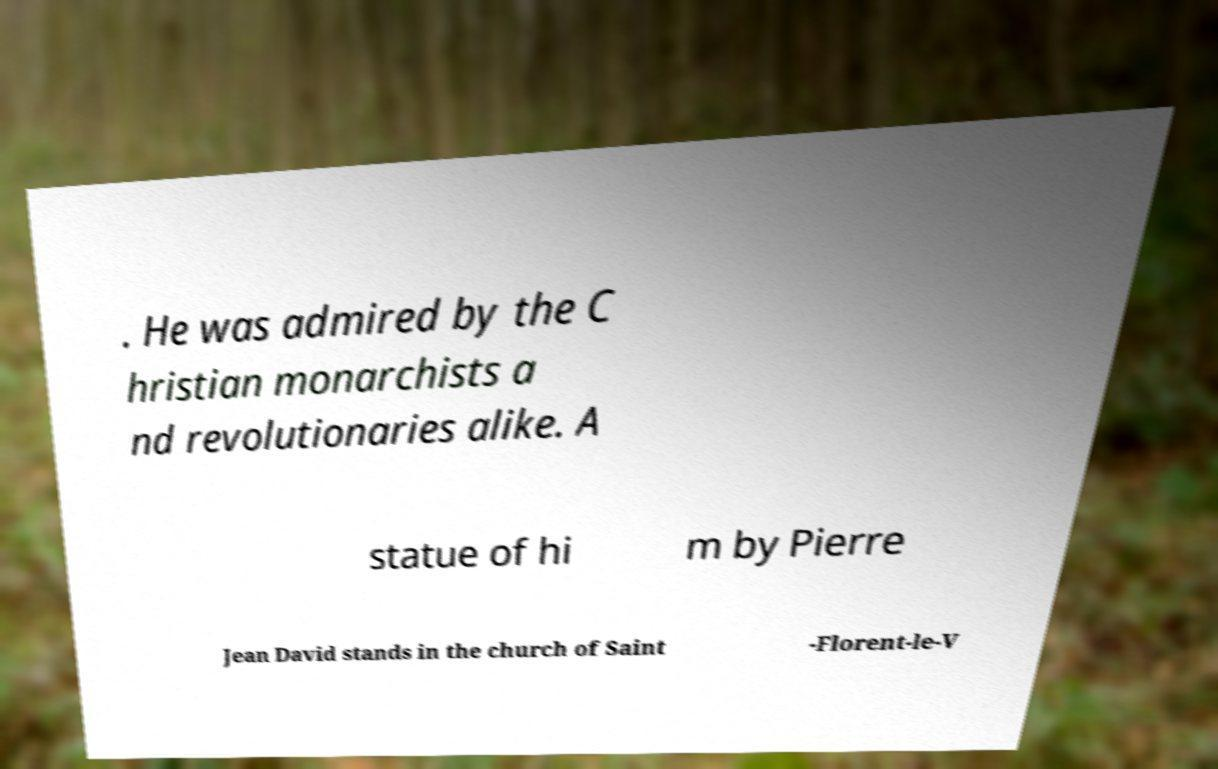For documentation purposes, I need the text within this image transcribed. Could you provide that? . He was admired by the C hristian monarchists a nd revolutionaries alike. A statue of hi m by Pierre Jean David stands in the church of Saint -Florent-le-V 